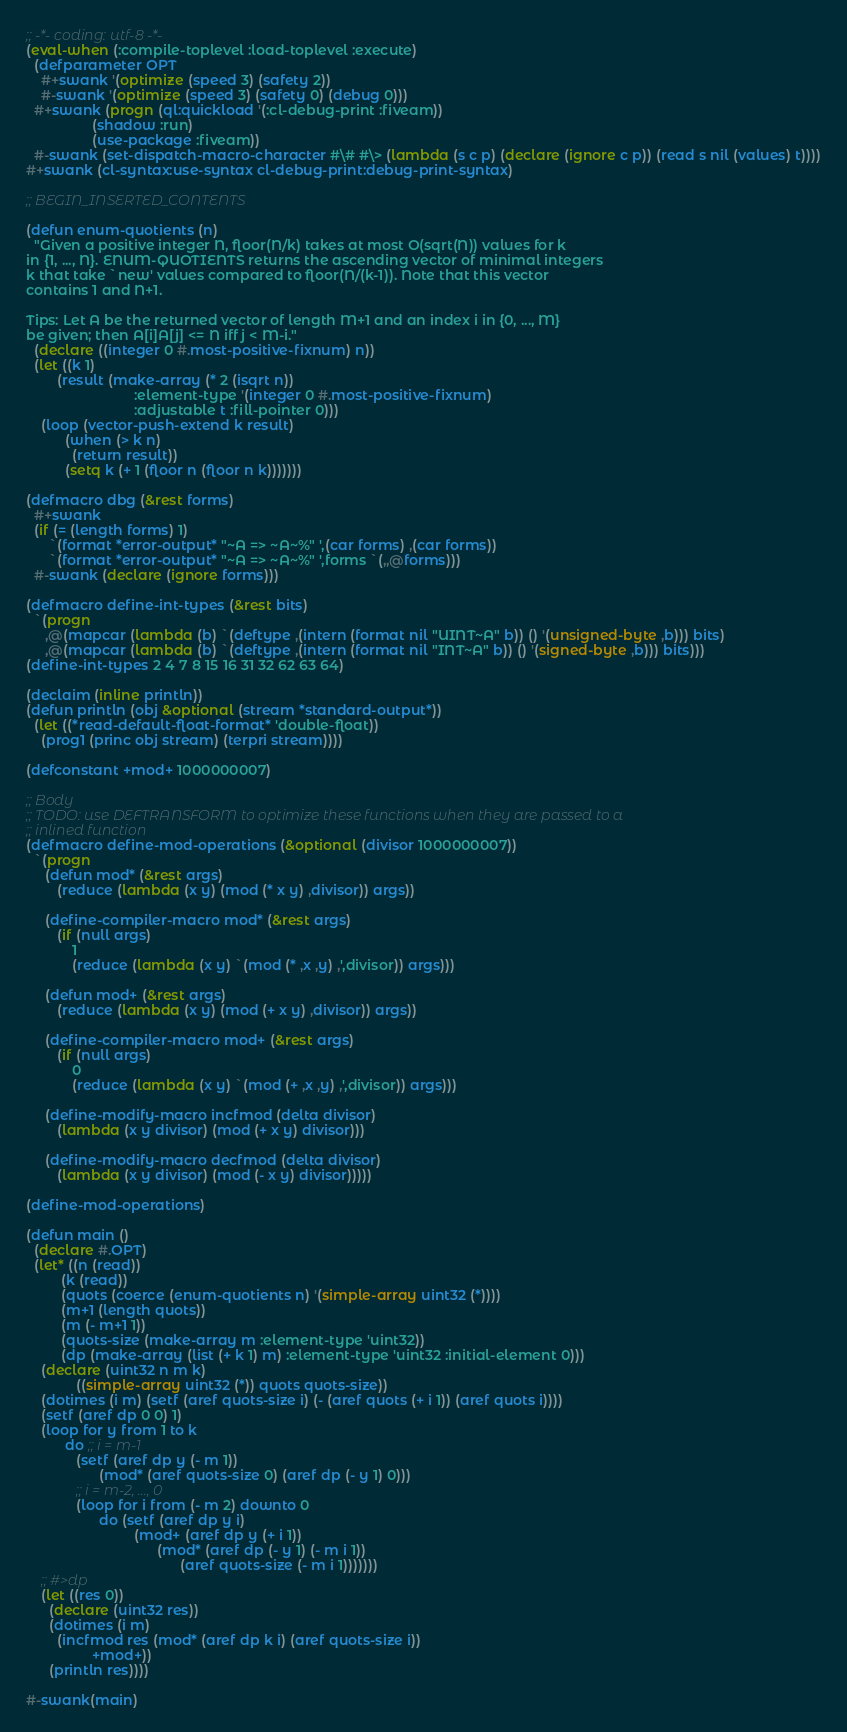<code> <loc_0><loc_0><loc_500><loc_500><_Lisp_>;; -*- coding: utf-8 -*-
(eval-when (:compile-toplevel :load-toplevel :execute)
  (defparameter OPT
    #+swank '(optimize (speed 3) (safety 2))
    #-swank '(optimize (speed 3) (safety 0) (debug 0)))
  #+swank (progn (ql:quickload '(:cl-debug-print :fiveam))
                 (shadow :run)
                 (use-package :fiveam))
  #-swank (set-dispatch-macro-character #\# #\> (lambda (s c p) (declare (ignore c p)) (read s nil (values) t))))
#+swank (cl-syntax:use-syntax cl-debug-print:debug-print-syntax)

;; BEGIN_INSERTED_CONTENTS

(defun enum-quotients (n)
  "Given a positive integer N, floor(N/k) takes at most O(sqrt(N)) values for k
in {1, ..., N}. ENUM-QUOTIENTS returns the ascending vector of minimal integers
k that take `new' values compared to floor(N/(k-1)). Note that this vector
contains 1 and N+1.

Tips: Let A be the returned vector of length M+1 and an index i in {0, ..., M}
be given; then A[i]A[j] <= N iff j < M-i."
  (declare ((integer 0 #.most-positive-fixnum) n))
  (let ((k 1)
        (result (make-array (* 2 (isqrt n))
                            :element-type '(integer 0 #.most-positive-fixnum)
                            :adjustable t :fill-pointer 0)))
    (loop (vector-push-extend k result)
          (when (> k n)
            (return result))
          (setq k (+ 1 (floor n (floor n k)))))))

(defmacro dbg (&rest forms)
  #+swank
  (if (= (length forms) 1)
      `(format *error-output* "~A => ~A~%" ',(car forms) ,(car forms))
      `(format *error-output* "~A => ~A~%" ',forms `(,,@forms)))
  #-swank (declare (ignore forms)))

(defmacro define-int-types (&rest bits)
  `(progn
     ,@(mapcar (lambda (b) `(deftype ,(intern (format nil "UINT~A" b)) () '(unsigned-byte ,b))) bits)
     ,@(mapcar (lambda (b) `(deftype ,(intern (format nil "INT~A" b)) () '(signed-byte ,b))) bits)))
(define-int-types 2 4 7 8 15 16 31 32 62 63 64)

(declaim (inline println))
(defun println (obj &optional (stream *standard-output*))
  (let ((*read-default-float-format* 'double-float))
    (prog1 (princ obj stream) (terpri stream))))

(defconstant +mod+ 1000000007)

;; Body
;; TODO: use DEFTRANSFORM to optimize these functions when they are passed to a
;; inlined function
(defmacro define-mod-operations (&optional (divisor 1000000007))
  `(progn
     (defun mod* (&rest args)
        (reduce (lambda (x y) (mod (* x y) ,divisor)) args))

     (define-compiler-macro mod* (&rest args)
        (if (null args)
            1
            (reduce (lambda (x y) `(mod (* ,x ,y) ,',divisor)) args)))

     (defun mod+ (&rest args)
        (reduce (lambda (x y) (mod (+ x y) ,divisor)) args))

     (define-compiler-macro mod+ (&rest args)
        (if (null args)
            0
            (reduce (lambda (x y) `(mod (+ ,x ,y) ,',divisor)) args)))

     (define-modify-macro incfmod (delta divisor)
        (lambda (x y divisor) (mod (+ x y) divisor)))

     (define-modify-macro decfmod (delta divisor)
        (lambda (x y divisor) (mod (- x y) divisor)))))

(define-mod-operations)

(defun main ()
  (declare #.OPT)
  (let* ((n (read))
         (k (read))
         (quots (coerce (enum-quotients n) '(simple-array uint32 (*))))
         (m+1 (length quots))
         (m (- m+1 1))
         (quots-size (make-array m :element-type 'uint32))
         (dp (make-array (list (+ k 1) m) :element-type 'uint32 :initial-element 0)))
    (declare (uint32 n m k)
             ((simple-array uint32 (*)) quots quots-size))
    (dotimes (i m) (setf (aref quots-size i) (- (aref quots (+ i 1)) (aref quots i))))
    (setf (aref dp 0 0) 1)
    (loop for y from 1 to k
          do ;; i = m-1
             (setf (aref dp y (- m 1))
                   (mod* (aref quots-size 0) (aref dp (- y 1) 0)))
             ;; i = m-2, ..., 0
             (loop for i from (- m 2) downto 0
                   do (setf (aref dp y i)
                            (mod+ (aref dp y (+ i 1))
                                  (mod* (aref dp (- y 1) (- m i 1))
                                        (aref quots-size (- m i 1)))))))
    ;; #>dp
    (let ((res 0))
      (declare (uint32 res))
      (dotimes (i m)
        (incfmod res (mod* (aref dp k i) (aref quots-size i))
                 +mod+))
      (println res))))

#-swank(main)
</code> 